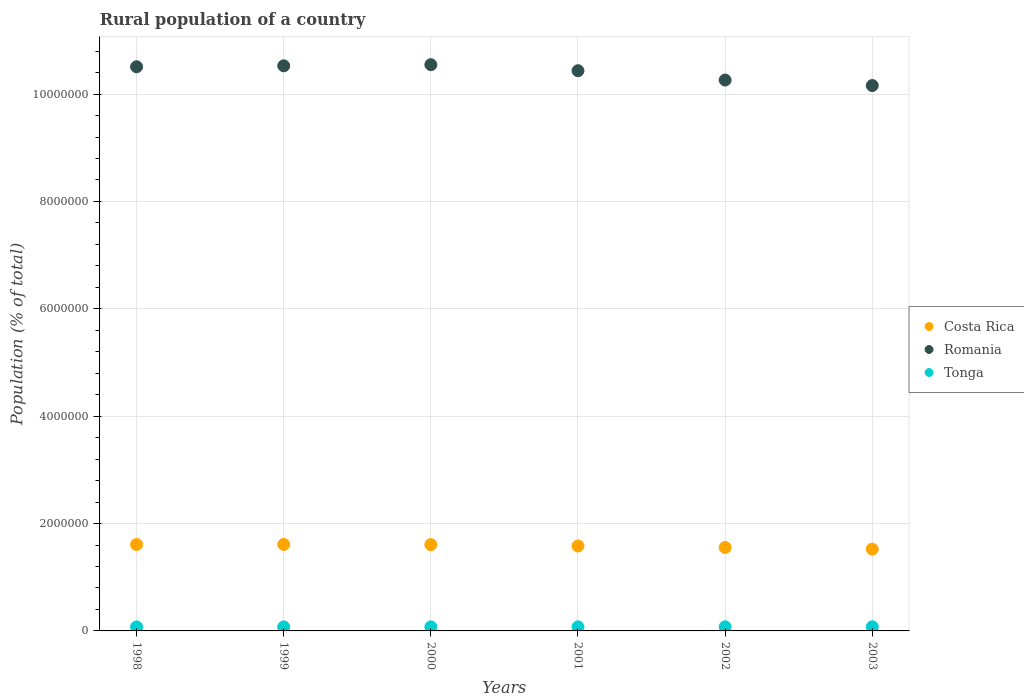What is the rural population in Tonga in 2001?
Keep it short and to the point. 7.58e+04. Across all years, what is the maximum rural population in Costa Rica?
Provide a succinct answer. 1.61e+06. Across all years, what is the minimum rural population in Costa Rica?
Your answer should be compact. 1.52e+06. In which year was the rural population in Tonga minimum?
Give a very brief answer. 1998. What is the total rural population in Romania in the graph?
Your answer should be compact. 6.24e+07. What is the difference between the rural population in Romania in 1998 and that in 2003?
Offer a terse response. 3.50e+05. What is the difference between the rural population in Costa Rica in 2002 and the rural population in Tonga in 2001?
Give a very brief answer. 1.48e+06. What is the average rural population in Romania per year?
Ensure brevity in your answer.  1.04e+07. In the year 1998, what is the difference between the rural population in Romania and rural population in Tonga?
Your answer should be compact. 1.04e+07. In how many years, is the rural population in Tonga greater than 400000 %?
Your answer should be very brief. 0. What is the ratio of the rural population in Romania in 2001 to that in 2002?
Give a very brief answer. 1.02. Is the rural population in Tonga in 1998 less than that in 2001?
Provide a short and direct response. Yes. Is the difference between the rural population in Romania in 1998 and 2002 greater than the difference between the rural population in Tonga in 1998 and 2002?
Offer a very short reply. Yes. What is the difference between the highest and the second highest rural population in Tonga?
Keep it short and to the point. 433. What is the difference between the highest and the lowest rural population in Tonga?
Provide a short and direct response. 1914. Is the rural population in Tonga strictly greater than the rural population in Costa Rica over the years?
Give a very brief answer. No. Is the rural population in Costa Rica strictly less than the rural population in Romania over the years?
Keep it short and to the point. Yes. How many dotlines are there?
Your response must be concise. 3. How many years are there in the graph?
Make the answer very short. 6. Does the graph contain any zero values?
Offer a very short reply. No. Does the graph contain grids?
Give a very brief answer. Yes. Where does the legend appear in the graph?
Offer a very short reply. Center right. What is the title of the graph?
Offer a terse response. Rural population of a country. What is the label or title of the Y-axis?
Keep it short and to the point. Population (% of total). What is the Population (% of total) of Costa Rica in 1998?
Keep it short and to the point. 1.61e+06. What is the Population (% of total) in Romania in 1998?
Give a very brief answer. 1.05e+07. What is the Population (% of total) in Tonga in 1998?
Provide a short and direct response. 7.47e+04. What is the Population (% of total) in Costa Rica in 1999?
Make the answer very short. 1.61e+06. What is the Population (% of total) of Romania in 1999?
Provide a short and direct response. 1.05e+07. What is the Population (% of total) of Tonga in 1999?
Offer a terse response. 7.50e+04. What is the Population (% of total) of Costa Rica in 2000?
Ensure brevity in your answer.  1.61e+06. What is the Population (% of total) in Romania in 2000?
Your answer should be very brief. 1.05e+07. What is the Population (% of total) of Tonga in 2000?
Give a very brief answer. 7.54e+04. What is the Population (% of total) in Costa Rica in 2001?
Offer a terse response. 1.58e+06. What is the Population (% of total) of Romania in 2001?
Provide a short and direct response. 1.04e+07. What is the Population (% of total) in Tonga in 2001?
Your response must be concise. 7.58e+04. What is the Population (% of total) in Costa Rica in 2002?
Offer a terse response. 1.55e+06. What is the Population (% of total) in Romania in 2002?
Ensure brevity in your answer.  1.03e+07. What is the Population (% of total) in Tonga in 2002?
Keep it short and to the point. 7.62e+04. What is the Population (% of total) in Costa Rica in 2003?
Offer a terse response. 1.52e+06. What is the Population (% of total) in Romania in 2003?
Provide a short and direct response. 1.02e+07. What is the Population (% of total) of Tonga in 2003?
Provide a short and direct response. 7.66e+04. Across all years, what is the maximum Population (% of total) of Costa Rica?
Ensure brevity in your answer.  1.61e+06. Across all years, what is the maximum Population (% of total) in Romania?
Provide a short and direct response. 1.05e+07. Across all years, what is the maximum Population (% of total) of Tonga?
Offer a very short reply. 7.66e+04. Across all years, what is the minimum Population (% of total) of Costa Rica?
Make the answer very short. 1.52e+06. Across all years, what is the minimum Population (% of total) of Romania?
Offer a terse response. 1.02e+07. Across all years, what is the minimum Population (% of total) of Tonga?
Offer a very short reply. 7.47e+04. What is the total Population (% of total) of Costa Rica in the graph?
Your answer should be very brief. 9.49e+06. What is the total Population (% of total) of Romania in the graph?
Ensure brevity in your answer.  6.24e+07. What is the total Population (% of total) in Tonga in the graph?
Make the answer very short. 4.54e+05. What is the difference between the Population (% of total) of Costa Rica in 1998 and that in 1999?
Your answer should be compact. -439. What is the difference between the Population (% of total) of Romania in 1998 and that in 1999?
Your answer should be compact. -1.79e+04. What is the difference between the Population (% of total) in Tonga in 1998 and that in 1999?
Keep it short and to the point. -327. What is the difference between the Population (% of total) of Costa Rica in 1998 and that in 2000?
Give a very brief answer. 2587. What is the difference between the Population (% of total) of Romania in 1998 and that in 2000?
Your answer should be compact. -3.88e+04. What is the difference between the Population (% of total) of Tonga in 1998 and that in 2000?
Provide a short and direct response. -685. What is the difference between the Population (% of total) in Costa Rica in 1998 and that in 2001?
Make the answer very short. 2.76e+04. What is the difference between the Population (% of total) of Romania in 1998 and that in 2001?
Your answer should be compact. 7.37e+04. What is the difference between the Population (% of total) in Tonga in 1998 and that in 2001?
Provide a short and direct response. -1069. What is the difference between the Population (% of total) in Costa Rica in 1998 and that in 2002?
Make the answer very short. 5.60e+04. What is the difference between the Population (% of total) in Romania in 1998 and that in 2002?
Make the answer very short. 2.47e+05. What is the difference between the Population (% of total) in Tonga in 1998 and that in 2002?
Give a very brief answer. -1481. What is the difference between the Population (% of total) in Costa Rica in 1998 and that in 2003?
Ensure brevity in your answer.  8.67e+04. What is the difference between the Population (% of total) of Romania in 1998 and that in 2003?
Give a very brief answer. 3.50e+05. What is the difference between the Population (% of total) in Tonga in 1998 and that in 2003?
Your response must be concise. -1914. What is the difference between the Population (% of total) of Costa Rica in 1999 and that in 2000?
Your answer should be compact. 3026. What is the difference between the Population (% of total) of Romania in 1999 and that in 2000?
Ensure brevity in your answer.  -2.09e+04. What is the difference between the Population (% of total) of Tonga in 1999 and that in 2000?
Your response must be concise. -358. What is the difference between the Population (% of total) in Costa Rica in 1999 and that in 2001?
Your answer should be very brief. 2.81e+04. What is the difference between the Population (% of total) of Romania in 1999 and that in 2001?
Make the answer very short. 9.16e+04. What is the difference between the Population (% of total) of Tonga in 1999 and that in 2001?
Your answer should be compact. -742. What is the difference between the Population (% of total) in Costa Rica in 1999 and that in 2002?
Your answer should be very brief. 5.64e+04. What is the difference between the Population (% of total) of Romania in 1999 and that in 2002?
Keep it short and to the point. 2.65e+05. What is the difference between the Population (% of total) in Tonga in 1999 and that in 2002?
Provide a succinct answer. -1154. What is the difference between the Population (% of total) of Costa Rica in 1999 and that in 2003?
Your response must be concise. 8.71e+04. What is the difference between the Population (% of total) in Romania in 1999 and that in 2003?
Keep it short and to the point. 3.67e+05. What is the difference between the Population (% of total) of Tonga in 1999 and that in 2003?
Offer a terse response. -1587. What is the difference between the Population (% of total) in Costa Rica in 2000 and that in 2001?
Ensure brevity in your answer.  2.51e+04. What is the difference between the Population (% of total) in Romania in 2000 and that in 2001?
Offer a terse response. 1.13e+05. What is the difference between the Population (% of total) in Tonga in 2000 and that in 2001?
Your response must be concise. -384. What is the difference between the Population (% of total) of Costa Rica in 2000 and that in 2002?
Give a very brief answer. 5.34e+04. What is the difference between the Population (% of total) of Romania in 2000 and that in 2002?
Your answer should be compact. 2.86e+05. What is the difference between the Population (% of total) of Tonga in 2000 and that in 2002?
Keep it short and to the point. -796. What is the difference between the Population (% of total) in Costa Rica in 2000 and that in 2003?
Make the answer very short. 8.41e+04. What is the difference between the Population (% of total) of Romania in 2000 and that in 2003?
Your answer should be compact. 3.88e+05. What is the difference between the Population (% of total) in Tonga in 2000 and that in 2003?
Provide a short and direct response. -1229. What is the difference between the Population (% of total) in Costa Rica in 2001 and that in 2002?
Make the answer very short. 2.83e+04. What is the difference between the Population (% of total) in Romania in 2001 and that in 2002?
Give a very brief answer. 1.74e+05. What is the difference between the Population (% of total) of Tonga in 2001 and that in 2002?
Give a very brief answer. -412. What is the difference between the Population (% of total) of Costa Rica in 2001 and that in 2003?
Keep it short and to the point. 5.90e+04. What is the difference between the Population (% of total) of Romania in 2001 and that in 2003?
Give a very brief answer. 2.76e+05. What is the difference between the Population (% of total) of Tonga in 2001 and that in 2003?
Ensure brevity in your answer.  -845. What is the difference between the Population (% of total) of Costa Rica in 2002 and that in 2003?
Your answer should be very brief. 3.07e+04. What is the difference between the Population (% of total) in Romania in 2002 and that in 2003?
Keep it short and to the point. 1.02e+05. What is the difference between the Population (% of total) of Tonga in 2002 and that in 2003?
Make the answer very short. -433. What is the difference between the Population (% of total) of Costa Rica in 1998 and the Population (% of total) of Romania in 1999?
Offer a terse response. -8.92e+06. What is the difference between the Population (% of total) of Costa Rica in 1998 and the Population (% of total) of Tonga in 1999?
Keep it short and to the point. 1.54e+06. What is the difference between the Population (% of total) in Romania in 1998 and the Population (% of total) in Tonga in 1999?
Offer a terse response. 1.04e+07. What is the difference between the Population (% of total) in Costa Rica in 1998 and the Population (% of total) in Romania in 2000?
Offer a very short reply. -8.94e+06. What is the difference between the Population (% of total) of Costa Rica in 1998 and the Population (% of total) of Tonga in 2000?
Your response must be concise. 1.53e+06. What is the difference between the Population (% of total) in Romania in 1998 and the Population (% of total) in Tonga in 2000?
Ensure brevity in your answer.  1.04e+07. What is the difference between the Population (% of total) of Costa Rica in 1998 and the Population (% of total) of Romania in 2001?
Provide a succinct answer. -8.82e+06. What is the difference between the Population (% of total) of Costa Rica in 1998 and the Population (% of total) of Tonga in 2001?
Your answer should be very brief. 1.53e+06. What is the difference between the Population (% of total) of Romania in 1998 and the Population (% of total) of Tonga in 2001?
Provide a succinct answer. 1.04e+07. What is the difference between the Population (% of total) in Costa Rica in 1998 and the Population (% of total) in Romania in 2002?
Give a very brief answer. -8.65e+06. What is the difference between the Population (% of total) of Costa Rica in 1998 and the Population (% of total) of Tonga in 2002?
Provide a succinct answer. 1.53e+06. What is the difference between the Population (% of total) in Romania in 1998 and the Population (% of total) in Tonga in 2002?
Offer a terse response. 1.04e+07. What is the difference between the Population (% of total) in Costa Rica in 1998 and the Population (% of total) in Romania in 2003?
Provide a short and direct response. -8.55e+06. What is the difference between the Population (% of total) in Costa Rica in 1998 and the Population (% of total) in Tonga in 2003?
Your response must be concise. 1.53e+06. What is the difference between the Population (% of total) in Romania in 1998 and the Population (% of total) in Tonga in 2003?
Your answer should be very brief. 1.04e+07. What is the difference between the Population (% of total) in Costa Rica in 1999 and the Population (% of total) in Romania in 2000?
Ensure brevity in your answer.  -8.94e+06. What is the difference between the Population (% of total) of Costa Rica in 1999 and the Population (% of total) of Tonga in 2000?
Offer a terse response. 1.54e+06. What is the difference between the Population (% of total) of Romania in 1999 and the Population (% of total) of Tonga in 2000?
Provide a short and direct response. 1.05e+07. What is the difference between the Population (% of total) in Costa Rica in 1999 and the Population (% of total) in Romania in 2001?
Offer a terse response. -8.82e+06. What is the difference between the Population (% of total) in Costa Rica in 1999 and the Population (% of total) in Tonga in 2001?
Your response must be concise. 1.53e+06. What is the difference between the Population (% of total) of Romania in 1999 and the Population (% of total) of Tonga in 2001?
Make the answer very short. 1.05e+07. What is the difference between the Population (% of total) in Costa Rica in 1999 and the Population (% of total) in Romania in 2002?
Give a very brief answer. -8.65e+06. What is the difference between the Population (% of total) of Costa Rica in 1999 and the Population (% of total) of Tonga in 2002?
Offer a very short reply. 1.53e+06. What is the difference between the Population (% of total) of Romania in 1999 and the Population (% of total) of Tonga in 2002?
Ensure brevity in your answer.  1.05e+07. What is the difference between the Population (% of total) of Costa Rica in 1999 and the Population (% of total) of Romania in 2003?
Provide a succinct answer. -8.55e+06. What is the difference between the Population (% of total) of Costa Rica in 1999 and the Population (% of total) of Tonga in 2003?
Your response must be concise. 1.53e+06. What is the difference between the Population (% of total) in Romania in 1999 and the Population (% of total) in Tonga in 2003?
Ensure brevity in your answer.  1.04e+07. What is the difference between the Population (% of total) in Costa Rica in 2000 and the Population (% of total) in Romania in 2001?
Give a very brief answer. -8.83e+06. What is the difference between the Population (% of total) in Costa Rica in 2000 and the Population (% of total) in Tonga in 2001?
Keep it short and to the point. 1.53e+06. What is the difference between the Population (% of total) of Romania in 2000 and the Population (% of total) of Tonga in 2001?
Offer a very short reply. 1.05e+07. What is the difference between the Population (% of total) of Costa Rica in 2000 and the Population (% of total) of Romania in 2002?
Offer a very short reply. -8.65e+06. What is the difference between the Population (% of total) in Costa Rica in 2000 and the Population (% of total) in Tonga in 2002?
Offer a terse response. 1.53e+06. What is the difference between the Population (% of total) of Romania in 2000 and the Population (% of total) of Tonga in 2002?
Keep it short and to the point. 1.05e+07. What is the difference between the Population (% of total) in Costa Rica in 2000 and the Population (% of total) in Romania in 2003?
Your response must be concise. -8.55e+06. What is the difference between the Population (% of total) of Costa Rica in 2000 and the Population (% of total) of Tonga in 2003?
Keep it short and to the point. 1.53e+06. What is the difference between the Population (% of total) of Romania in 2000 and the Population (% of total) of Tonga in 2003?
Provide a short and direct response. 1.05e+07. What is the difference between the Population (% of total) of Costa Rica in 2001 and the Population (% of total) of Romania in 2002?
Ensure brevity in your answer.  -8.68e+06. What is the difference between the Population (% of total) of Costa Rica in 2001 and the Population (% of total) of Tonga in 2002?
Your answer should be compact. 1.51e+06. What is the difference between the Population (% of total) of Romania in 2001 and the Population (% of total) of Tonga in 2002?
Provide a succinct answer. 1.04e+07. What is the difference between the Population (% of total) of Costa Rica in 2001 and the Population (% of total) of Romania in 2003?
Keep it short and to the point. -8.58e+06. What is the difference between the Population (% of total) of Costa Rica in 2001 and the Population (% of total) of Tonga in 2003?
Make the answer very short. 1.51e+06. What is the difference between the Population (% of total) of Romania in 2001 and the Population (% of total) of Tonga in 2003?
Ensure brevity in your answer.  1.04e+07. What is the difference between the Population (% of total) of Costa Rica in 2002 and the Population (% of total) of Romania in 2003?
Your response must be concise. -8.60e+06. What is the difference between the Population (% of total) in Costa Rica in 2002 and the Population (% of total) in Tonga in 2003?
Keep it short and to the point. 1.48e+06. What is the difference between the Population (% of total) of Romania in 2002 and the Population (% of total) of Tonga in 2003?
Give a very brief answer. 1.02e+07. What is the average Population (% of total) in Costa Rica per year?
Keep it short and to the point. 1.58e+06. What is the average Population (% of total) in Romania per year?
Your answer should be very brief. 1.04e+07. What is the average Population (% of total) in Tonga per year?
Your answer should be very brief. 7.56e+04. In the year 1998, what is the difference between the Population (% of total) in Costa Rica and Population (% of total) in Romania?
Your answer should be compact. -8.90e+06. In the year 1998, what is the difference between the Population (% of total) of Costa Rica and Population (% of total) of Tonga?
Ensure brevity in your answer.  1.54e+06. In the year 1998, what is the difference between the Population (% of total) of Romania and Population (% of total) of Tonga?
Provide a short and direct response. 1.04e+07. In the year 1999, what is the difference between the Population (% of total) of Costa Rica and Population (% of total) of Romania?
Offer a very short reply. -8.92e+06. In the year 1999, what is the difference between the Population (% of total) in Costa Rica and Population (% of total) in Tonga?
Your response must be concise. 1.54e+06. In the year 1999, what is the difference between the Population (% of total) of Romania and Population (% of total) of Tonga?
Ensure brevity in your answer.  1.05e+07. In the year 2000, what is the difference between the Population (% of total) of Costa Rica and Population (% of total) of Romania?
Provide a short and direct response. -8.94e+06. In the year 2000, what is the difference between the Population (% of total) of Costa Rica and Population (% of total) of Tonga?
Offer a terse response. 1.53e+06. In the year 2000, what is the difference between the Population (% of total) in Romania and Population (% of total) in Tonga?
Offer a very short reply. 1.05e+07. In the year 2001, what is the difference between the Population (% of total) in Costa Rica and Population (% of total) in Romania?
Provide a short and direct response. -8.85e+06. In the year 2001, what is the difference between the Population (% of total) of Costa Rica and Population (% of total) of Tonga?
Make the answer very short. 1.51e+06. In the year 2001, what is the difference between the Population (% of total) in Romania and Population (% of total) in Tonga?
Provide a succinct answer. 1.04e+07. In the year 2002, what is the difference between the Population (% of total) in Costa Rica and Population (% of total) in Romania?
Give a very brief answer. -8.71e+06. In the year 2002, what is the difference between the Population (% of total) in Costa Rica and Population (% of total) in Tonga?
Provide a succinct answer. 1.48e+06. In the year 2002, what is the difference between the Population (% of total) in Romania and Population (% of total) in Tonga?
Ensure brevity in your answer.  1.02e+07. In the year 2003, what is the difference between the Population (% of total) of Costa Rica and Population (% of total) of Romania?
Make the answer very short. -8.64e+06. In the year 2003, what is the difference between the Population (% of total) of Costa Rica and Population (% of total) of Tonga?
Your answer should be very brief. 1.45e+06. In the year 2003, what is the difference between the Population (% of total) of Romania and Population (% of total) of Tonga?
Give a very brief answer. 1.01e+07. What is the ratio of the Population (% of total) of Romania in 1998 to that in 1999?
Offer a terse response. 1. What is the ratio of the Population (% of total) of Costa Rica in 1998 to that in 2000?
Your answer should be compact. 1. What is the ratio of the Population (% of total) in Romania in 1998 to that in 2000?
Keep it short and to the point. 1. What is the ratio of the Population (% of total) in Tonga in 1998 to that in 2000?
Give a very brief answer. 0.99. What is the ratio of the Population (% of total) of Costa Rica in 1998 to that in 2001?
Offer a terse response. 1.02. What is the ratio of the Population (% of total) in Romania in 1998 to that in 2001?
Ensure brevity in your answer.  1.01. What is the ratio of the Population (% of total) in Tonga in 1998 to that in 2001?
Make the answer very short. 0.99. What is the ratio of the Population (% of total) in Costa Rica in 1998 to that in 2002?
Your answer should be compact. 1.04. What is the ratio of the Population (% of total) in Romania in 1998 to that in 2002?
Your answer should be very brief. 1.02. What is the ratio of the Population (% of total) of Tonga in 1998 to that in 2002?
Offer a terse response. 0.98. What is the ratio of the Population (% of total) in Costa Rica in 1998 to that in 2003?
Your answer should be very brief. 1.06. What is the ratio of the Population (% of total) in Romania in 1998 to that in 2003?
Provide a succinct answer. 1.03. What is the ratio of the Population (% of total) in Tonga in 1998 to that in 2003?
Provide a short and direct response. 0.97. What is the ratio of the Population (% of total) in Costa Rica in 1999 to that in 2000?
Ensure brevity in your answer.  1. What is the ratio of the Population (% of total) in Romania in 1999 to that in 2000?
Your answer should be compact. 1. What is the ratio of the Population (% of total) of Tonga in 1999 to that in 2000?
Keep it short and to the point. 1. What is the ratio of the Population (% of total) of Costa Rica in 1999 to that in 2001?
Keep it short and to the point. 1.02. What is the ratio of the Population (% of total) in Romania in 1999 to that in 2001?
Provide a succinct answer. 1.01. What is the ratio of the Population (% of total) in Tonga in 1999 to that in 2001?
Offer a very short reply. 0.99. What is the ratio of the Population (% of total) in Costa Rica in 1999 to that in 2002?
Keep it short and to the point. 1.04. What is the ratio of the Population (% of total) in Romania in 1999 to that in 2002?
Your answer should be compact. 1.03. What is the ratio of the Population (% of total) of Costa Rica in 1999 to that in 2003?
Keep it short and to the point. 1.06. What is the ratio of the Population (% of total) in Romania in 1999 to that in 2003?
Offer a terse response. 1.04. What is the ratio of the Population (% of total) in Tonga in 1999 to that in 2003?
Your answer should be very brief. 0.98. What is the ratio of the Population (% of total) of Costa Rica in 2000 to that in 2001?
Offer a terse response. 1.02. What is the ratio of the Population (% of total) in Romania in 2000 to that in 2001?
Provide a short and direct response. 1.01. What is the ratio of the Population (% of total) of Tonga in 2000 to that in 2001?
Offer a terse response. 0.99. What is the ratio of the Population (% of total) in Costa Rica in 2000 to that in 2002?
Provide a succinct answer. 1.03. What is the ratio of the Population (% of total) in Romania in 2000 to that in 2002?
Provide a succinct answer. 1.03. What is the ratio of the Population (% of total) in Tonga in 2000 to that in 2002?
Make the answer very short. 0.99. What is the ratio of the Population (% of total) in Costa Rica in 2000 to that in 2003?
Your answer should be compact. 1.06. What is the ratio of the Population (% of total) in Romania in 2000 to that in 2003?
Provide a short and direct response. 1.04. What is the ratio of the Population (% of total) of Tonga in 2000 to that in 2003?
Provide a short and direct response. 0.98. What is the ratio of the Population (% of total) of Costa Rica in 2001 to that in 2002?
Offer a very short reply. 1.02. What is the ratio of the Population (% of total) in Romania in 2001 to that in 2002?
Keep it short and to the point. 1.02. What is the ratio of the Population (% of total) in Costa Rica in 2001 to that in 2003?
Offer a terse response. 1.04. What is the ratio of the Population (% of total) in Romania in 2001 to that in 2003?
Offer a terse response. 1.03. What is the ratio of the Population (% of total) of Tonga in 2001 to that in 2003?
Provide a succinct answer. 0.99. What is the ratio of the Population (% of total) of Costa Rica in 2002 to that in 2003?
Keep it short and to the point. 1.02. What is the difference between the highest and the second highest Population (% of total) in Costa Rica?
Your answer should be compact. 439. What is the difference between the highest and the second highest Population (% of total) of Romania?
Offer a terse response. 2.09e+04. What is the difference between the highest and the second highest Population (% of total) of Tonga?
Ensure brevity in your answer.  433. What is the difference between the highest and the lowest Population (% of total) in Costa Rica?
Provide a succinct answer. 8.71e+04. What is the difference between the highest and the lowest Population (% of total) of Romania?
Give a very brief answer. 3.88e+05. What is the difference between the highest and the lowest Population (% of total) in Tonga?
Your answer should be very brief. 1914. 